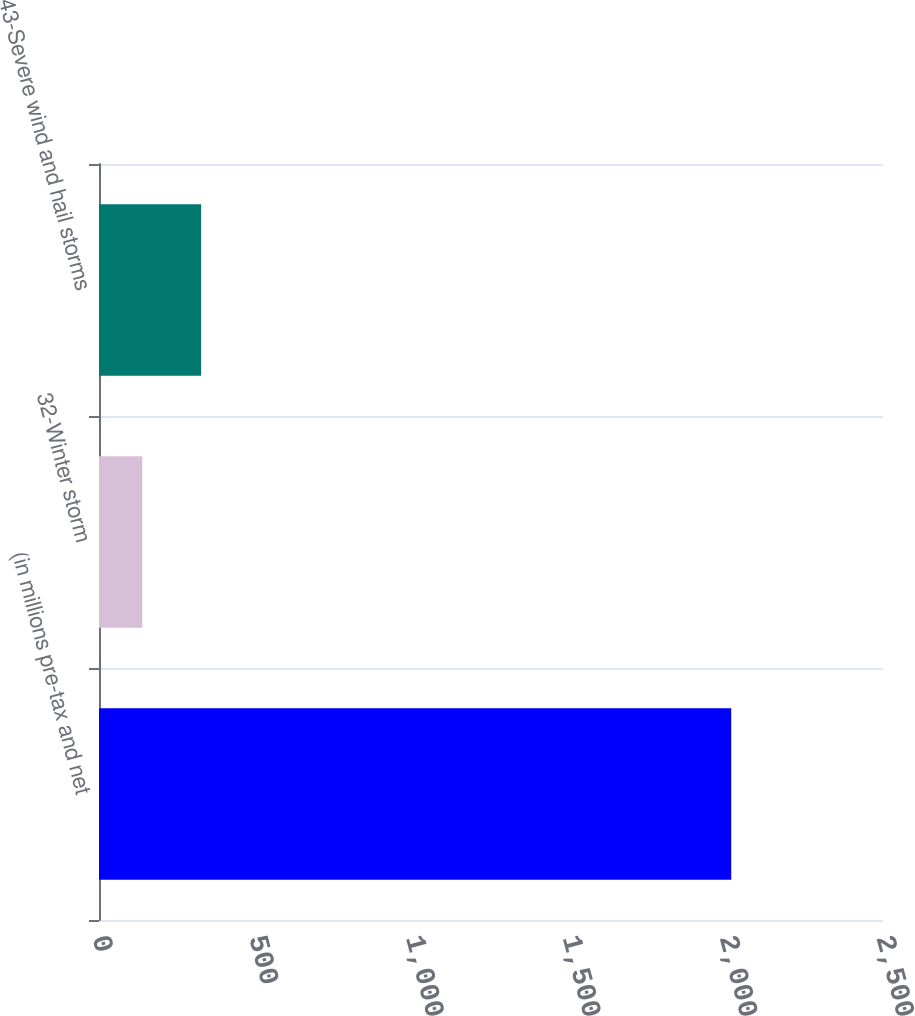<chart> <loc_0><loc_0><loc_500><loc_500><bar_chart><fcel>(in millions pre-tax and net<fcel>32-Winter storm<fcel>43-Severe wind and hail storms<nl><fcel>2016<fcel>138<fcel>325.8<nl></chart> 